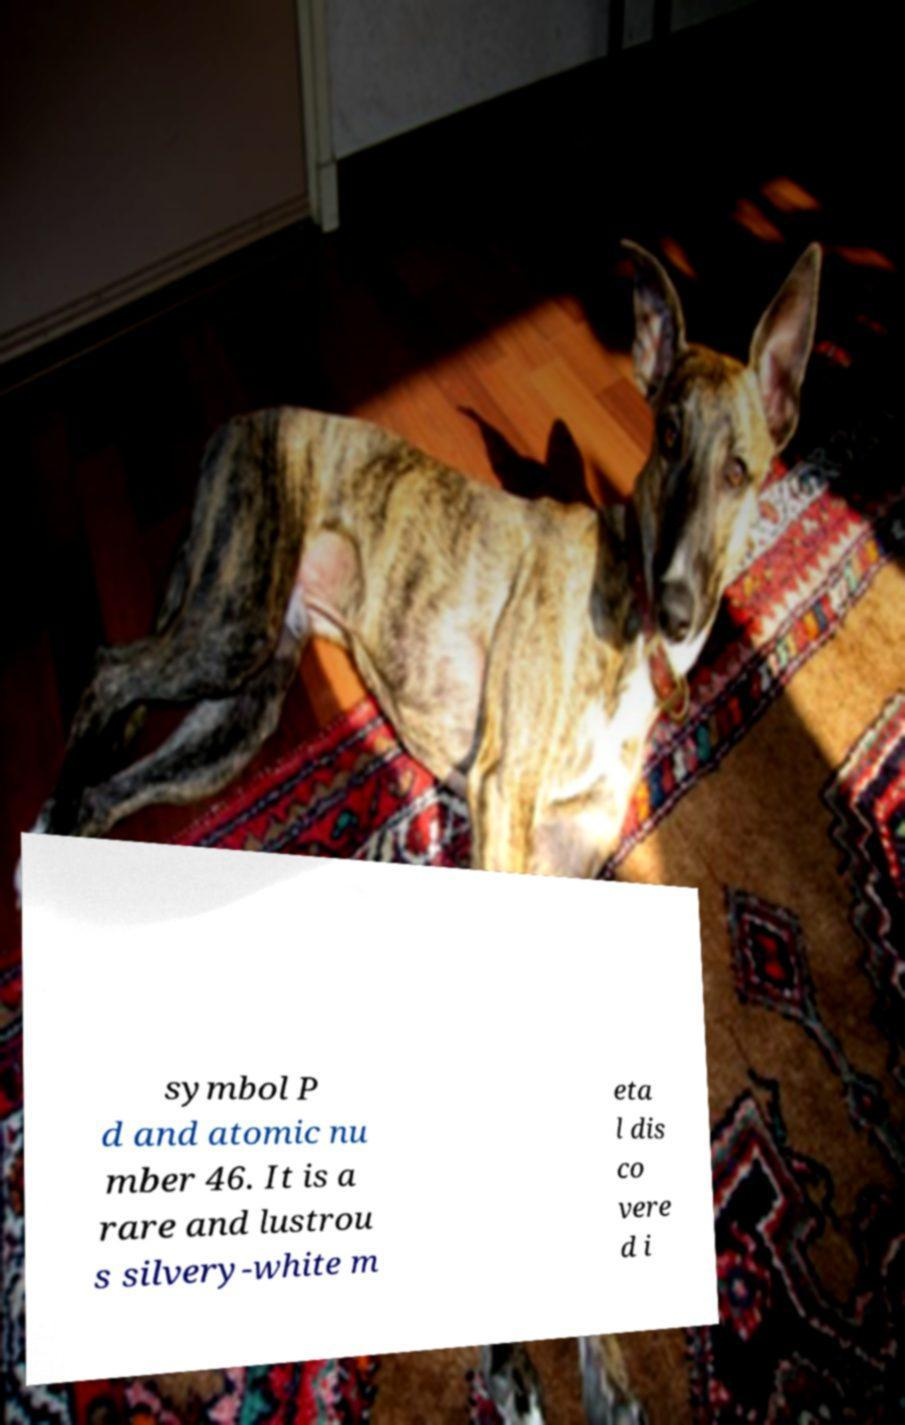Could you extract and type out the text from this image? symbol P d and atomic nu mber 46. It is a rare and lustrou s silvery-white m eta l dis co vere d i 